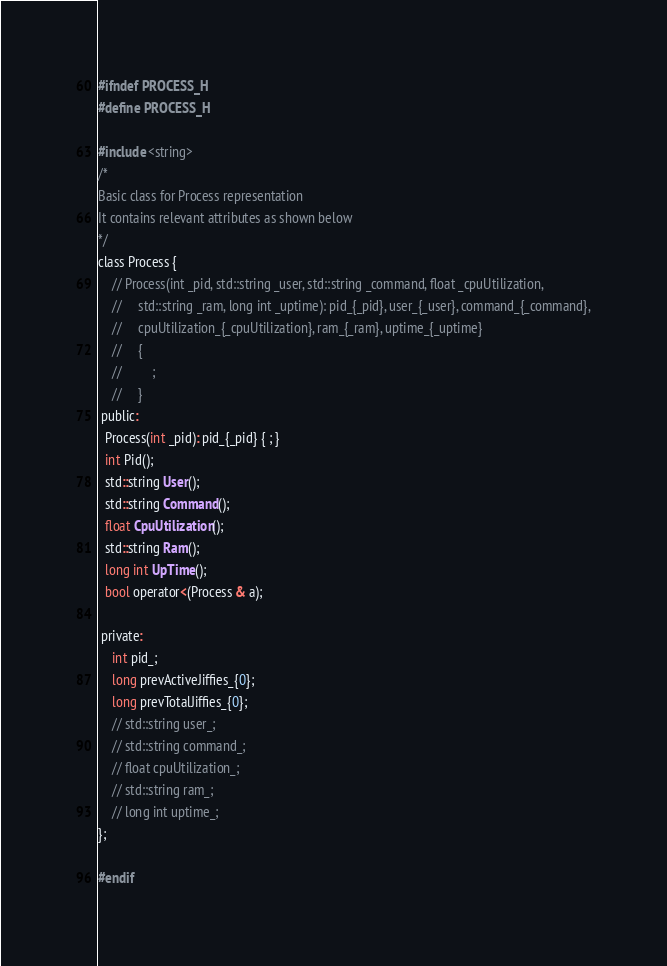<code> <loc_0><loc_0><loc_500><loc_500><_C_>#ifndef PROCESS_H
#define PROCESS_H

#include <string>
/*
Basic class for Process representation
It contains relevant attributes as shown below
*/
class Process {
    // Process(int _pid, std::string _user, std::string _command, float _cpuUtilization,
    //     std::string _ram, long int _uptime): pid_{_pid}, user_{_user}, command_{_command},
    //     cpuUtilization_{_cpuUtilization}, ram_{_ram}, uptime_{_uptime}
    //     {
    //         ;
    //     }
 public:
  Process(int _pid): pid_{_pid} { ; }
  int Pid();
  std::string User();
  std::string Command();
  float CpuUtilization();
  std::string Ram();
  long int UpTime();
  bool operator<(Process & a);

 private:
    int pid_;
    long prevActiveJiffies_{0};
    long prevTotalJiffies_{0};
    // std::string user_;
    // std::string command_;
    // float cpuUtilization_;
    // std::string ram_;
    // long int uptime_;
};

#endif</code> 